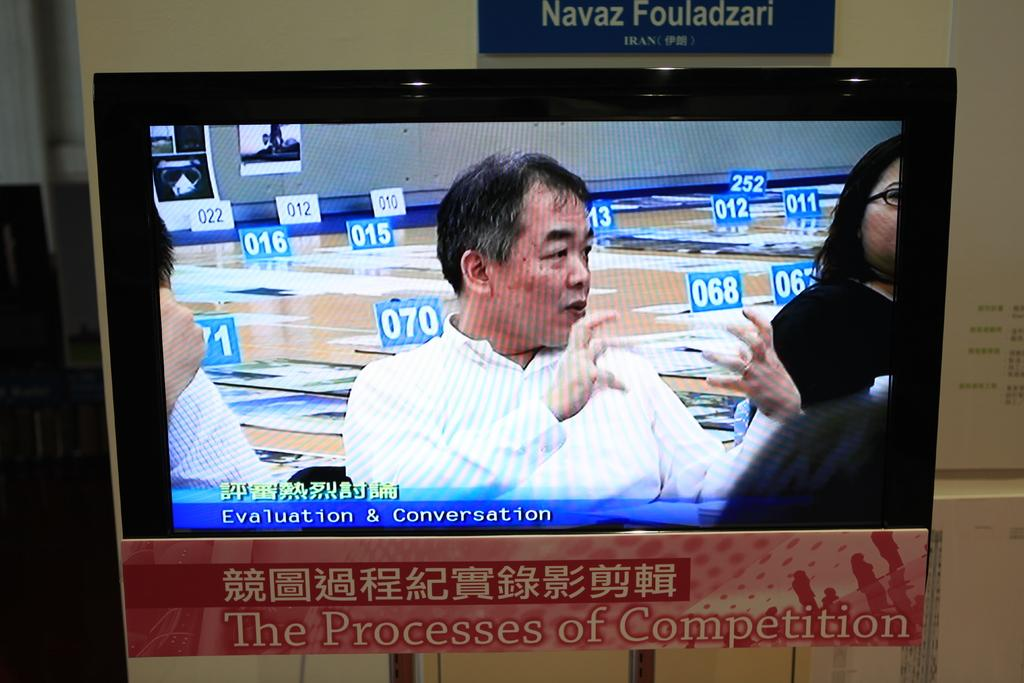<image>
Describe the image concisely. A television with a sign that says The Processes of Competition below it. 